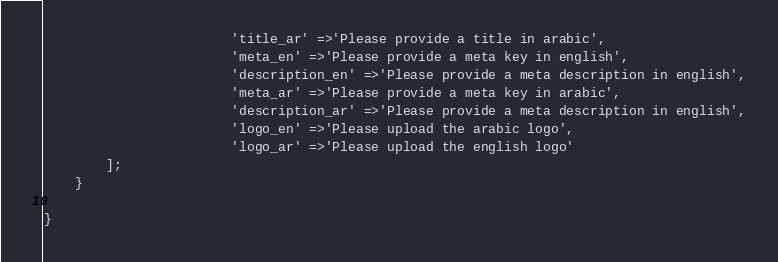Convert code to text. <code><loc_0><loc_0><loc_500><loc_500><_PHP_>						'title_ar' =>'Please provide a title in arabic',
						'meta_en' =>'Please provide a meta key in english',
						'description_en' =>'Please provide a meta description in english',
						'meta_ar' =>'Please provide a meta key in arabic',
						'description_ar' =>'Please provide a meta description in english',
						'logo_en' =>'Please upload the arabic logo',
						'logo_ar' =>'Please upload the english logo'
        ];
    }

}
</code> 